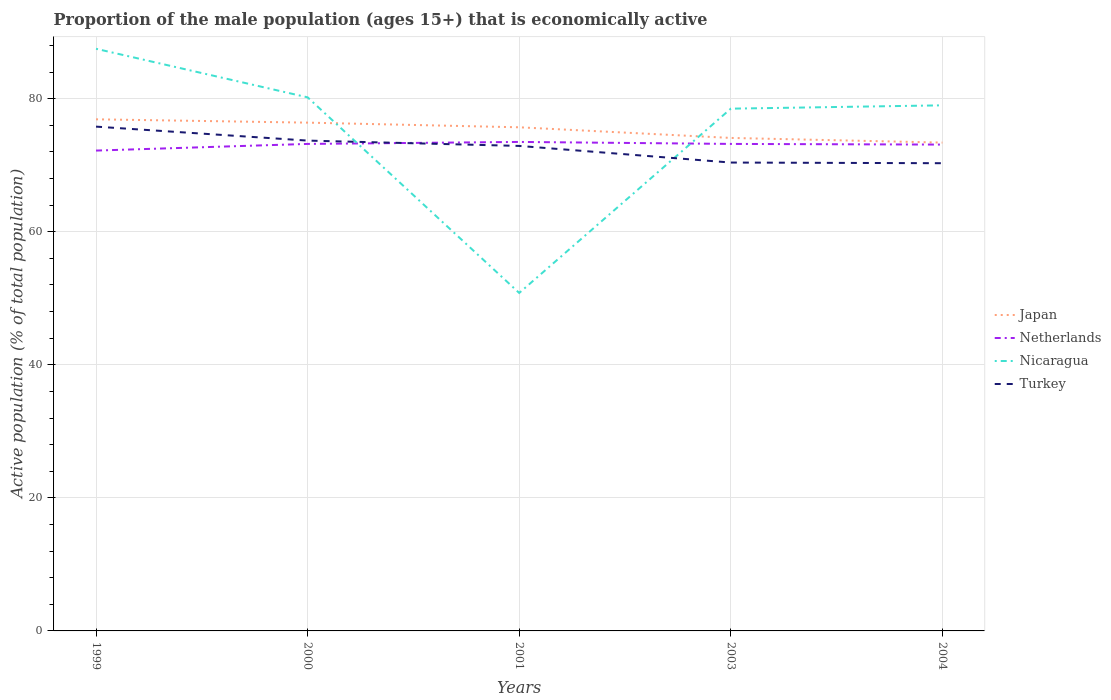Across all years, what is the maximum proportion of the male population that is economically active in Turkey?
Your answer should be very brief. 70.3. In which year was the proportion of the male population that is economically active in Netherlands maximum?
Provide a short and direct response. 1999. What is the total proportion of the male population that is economically active in Netherlands in the graph?
Provide a short and direct response. -1.3. What is the difference between the highest and the second highest proportion of the male population that is economically active in Japan?
Your answer should be very brief. 3.5. How many years are there in the graph?
Ensure brevity in your answer.  5. Are the values on the major ticks of Y-axis written in scientific E-notation?
Your response must be concise. No. Where does the legend appear in the graph?
Your answer should be very brief. Center right. How many legend labels are there?
Your response must be concise. 4. What is the title of the graph?
Your answer should be very brief. Proportion of the male population (ages 15+) that is economically active. Does "Tonga" appear as one of the legend labels in the graph?
Provide a short and direct response. No. What is the label or title of the X-axis?
Ensure brevity in your answer.  Years. What is the label or title of the Y-axis?
Keep it short and to the point. Active population (% of total population). What is the Active population (% of total population) in Japan in 1999?
Provide a succinct answer. 76.9. What is the Active population (% of total population) in Netherlands in 1999?
Make the answer very short. 72.2. What is the Active population (% of total population) of Nicaragua in 1999?
Offer a terse response. 87.5. What is the Active population (% of total population) of Turkey in 1999?
Provide a succinct answer. 75.8. What is the Active population (% of total population) in Japan in 2000?
Provide a succinct answer. 76.4. What is the Active population (% of total population) of Netherlands in 2000?
Your answer should be compact. 73.2. What is the Active population (% of total population) in Nicaragua in 2000?
Make the answer very short. 80.2. What is the Active population (% of total population) of Turkey in 2000?
Offer a terse response. 73.7. What is the Active population (% of total population) of Japan in 2001?
Your response must be concise. 75.7. What is the Active population (% of total population) in Netherlands in 2001?
Provide a succinct answer. 73.5. What is the Active population (% of total population) in Nicaragua in 2001?
Provide a succinct answer. 50.8. What is the Active population (% of total population) of Turkey in 2001?
Make the answer very short. 72.9. What is the Active population (% of total population) of Japan in 2003?
Keep it short and to the point. 74.1. What is the Active population (% of total population) of Netherlands in 2003?
Your response must be concise. 73.2. What is the Active population (% of total population) in Nicaragua in 2003?
Your response must be concise. 78.5. What is the Active population (% of total population) of Turkey in 2003?
Your answer should be compact. 70.4. What is the Active population (% of total population) in Japan in 2004?
Provide a short and direct response. 73.4. What is the Active population (% of total population) in Netherlands in 2004?
Offer a terse response. 73.1. What is the Active population (% of total population) in Nicaragua in 2004?
Give a very brief answer. 79. What is the Active population (% of total population) of Turkey in 2004?
Provide a short and direct response. 70.3. Across all years, what is the maximum Active population (% of total population) of Japan?
Your response must be concise. 76.9. Across all years, what is the maximum Active population (% of total population) of Netherlands?
Offer a terse response. 73.5. Across all years, what is the maximum Active population (% of total population) in Nicaragua?
Ensure brevity in your answer.  87.5. Across all years, what is the maximum Active population (% of total population) of Turkey?
Keep it short and to the point. 75.8. Across all years, what is the minimum Active population (% of total population) in Japan?
Make the answer very short. 73.4. Across all years, what is the minimum Active population (% of total population) of Netherlands?
Make the answer very short. 72.2. Across all years, what is the minimum Active population (% of total population) of Nicaragua?
Offer a very short reply. 50.8. Across all years, what is the minimum Active population (% of total population) in Turkey?
Make the answer very short. 70.3. What is the total Active population (% of total population) in Japan in the graph?
Your answer should be compact. 376.5. What is the total Active population (% of total population) of Netherlands in the graph?
Give a very brief answer. 365.2. What is the total Active population (% of total population) in Nicaragua in the graph?
Offer a very short reply. 376. What is the total Active population (% of total population) of Turkey in the graph?
Provide a succinct answer. 363.1. What is the difference between the Active population (% of total population) in Nicaragua in 1999 and that in 2000?
Ensure brevity in your answer.  7.3. What is the difference between the Active population (% of total population) in Nicaragua in 1999 and that in 2001?
Your answer should be compact. 36.7. What is the difference between the Active population (% of total population) of Netherlands in 1999 and that in 2003?
Offer a terse response. -1. What is the difference between the Active population (% of total population) in Nicaragua in 1999 and that in 2003?
Provide a short and direct response. 9. What is the difference between the Active population (% of total population) of Turkey in 1999 and that in 2003?
Your answer should be compact. 5.4. What is the difference between the Active population (% of total population) in Japan in 1999 and that in 2004?
Provide a succinct answer. 3.5. What is the difference between the Active population (% of total population) in Turkey in 1999 and that in 2004?
Provide a succinct answer. 5.5. What is the difference between the Active population (% of total population) in Japan in 2000 and that in 2001?
Your response must be concise. 0.7. What is the difference between the Active population (% of total population) of Nicaragua in 2000 and that in 2001?
Keep it short and to the point. 29.4. What is the difference between the Active population (% of total population) of Netherlands in 2000 and that in 2003?
Make the answer very short. 0. What is the difference between the Active population (% of total population) in Nicaragua in 2000 and that in 2003?
Ensure brevity in your answer.  1.7. What is the difference between the Active population (% of total population) of Turkey in 2000 and that in 2003?
Ensure brevity in your answer.  3.3. What is the difference between the Active population (% of total population) in Japan in 2000 and that in 2004?
Provide a short and direct response. 3. What is the difference between the Active population (% of total population) of Nicaragua in 2000 and that in 2004?
Your answer should be very brief. 1.2. What is the difference between the Active population (% of total population) in Japan in 2001 and that in 2003?
Your response must be concise. 1.6. What is the difference between the Active population (% of total population) of Netherlands in 2001 and that in 2003?
Your answer should be compact. 0.3. What is the difference between the Active population (% of total population) of Nicaragua in 2001 and that in 2003?
Offer a terse response. -27.7. What is the difference between the Active population (% of total population) of Nicaragua in 2001 and that in 2004?
Your answer should be compact. -28.2. What is the difference between the Active population (% of total population) of Turkey in 2001 and that in 2004?
Offer a very short reply. 2.6. What is the difference between the Active population (% of total population) of Netherlands in 2003 and that in 2004?
Offer a terse response. 0.1. What is the difference between the Active population (% of total population) in Japan in 1999 and the Active population (% of total population) in Netherlands in 2000?
Give a very brief answer. 3.7. What is the difference between the Active population (% of total population) in Netherlands in 1999 and the Active population (% of total population) in Turkey in 2000?
Provide a succinct answer. -1.5. What is the difference between the Active population (% of total population) of Nicaragua in 1999 and the Active population (% of total population) of Turkey in 2000?
Provide a short and direct response. 13.8. What is the difference between the Active population (% of total population) of Japan in 1999 and the Active population (% of total population) of Nicaragua in 2001?
Keep it short and to the point. 26.1. What is the difference between the Active population (% of total population) in Japan in 1999 and the Active population (% of total population) in Turkey in 2001?
Provide a succinct answer. 4. What is the difference between the Active population (% of total population) of Netherlands in 1999 and the Active population (% of total population) of Nicaragua in 2001?
Provide a short and direct response. 21.4. What is the difference between the Active population (% of total population) in Japan in 1999 and the Active population (% of total population) in Nicaragua in 2003?
Make the answer very short. -1.6. What is the difference between the Active population (% of total population) of Netherlands in 1999 and the Active population (% of total population) of Turkey in 2003?
Provide a short and direct response. 1.8. What is the difference between the Active population (% of total population) of Japan in 1999 and the Active population (% of total population) of Netherlands in 2004?
Offer a terse response. 3.8. What is the difference between the Active population (% of total population) in Japan in 2000 and the Active population (% of total population) in Netherlands in 2001?
Keep it short and to the point. 2.9. What is the difference between the Active population (% of total population) of Japan in 2000 and the Active population (% of total population) of Nicaragua in 2001?
Your answer should be compact. 25.6. What is the difference between the Active population (% of total population) of Japan in 2000 and the Active population (% of total population) of Turkey in 2001?
Your answer should be compact. 3.5. What is the difference between the Active population (% of total population) in Netherlands in 2000 and the Active population (% of total population) in Nicaragua in 2001?
Provide a short and direct response. 22.4. What is the difference between the Active population (% of total population) in Japan in 2000 and the Active population (% of total population) in Netherlands in 2003?
Give a very brief answer. 3.2. What is the difference between the Active population (% of total population) of Japan in 2000 and the Active population (% of total population) of Nicaragua in 2003?
Give a very brief answer. -2.1. What is the difference between the Active population (% of total population) of Japan in 2000 and the Active population (% of total population) of Turkey in 2003?
Offer a very short reply. 6. What is the difference between the Active population (% of total population) of Netherlands in 2000 and the Active population (% of total population) of Nicaragua in 2003?
Keep it short and to the point. -5.3. What is the difference between the Active population (% of total population) in Japan in 2000 and the Active population (% of total population) in Nicaragua in 2004?
Offer a very short reply. -2.6. What is the difference between the Active population (% of total population) in Japan in 2000 and the Active population (% of total population) in Turkey in 2004?
Your response must be concise. 6.1. What is the difference between the Active population (% of total population) in Nicaragua in 2000 and the Active population (% of total population) in Turkey in 2004?
Make the answer very short. 9.9. What is the difference between the Active population (% of total population) in Japan in 2001 and the Active population (% of total population) in Netherlands in 2003?
Provide a short and direct response. 2.5. What is the difference between the Active population (% of total population) of Japan in 2001 and the Active population (% of total population) of Nicaragua in 2003?
Make the answer very short. -2.8. What is the difference between the Active population (% of total population) in Netherlands in 2001 and the Active population (% of total population) in Nicaragua in 2003?
Keep it short and to the point. -5. What is the difference between the Active population (% of total population) of Nicaragua in 2001 and the Active population (% of total population) of Turkey in 2003?
Offer a very short reply. -19.6. What is the difference between the Active population (% of total population) of Japan in 2001 and the Active population (% of total population) of Nicaragua in 2004?
Offer a terse response. -3.3. What is the difference between the Active population (% of total population) of Japan in 2001 and the Active population (% of total population) of Turkey in 2004?
Offer a terse response. 5.4. What is the difference between the Active population (% of total population) in Netherlands in 2001 and the Active population (% of total population) in Turkey in 2004?
Keep it short and to the point. 3.2. What is the difference between the Active population (% of total population) in Nicaragua in 2001 and the Active population (% of total population) in Turkey in 2004?
Offer a terse response. -19.5. What is the difference between the Active population (% of total population) of Netherlands in 2003 and the Active population (% of total population) of Nicaragua in 2004?
Provide a succinct answer. -5.8. What is the average Active population (% of total population) of Japan per year?
Offer a terse response. 75.3. What is the average Active population (% of total population) of Netherlands per year?
Provide a short and direct response. 73.04. What is the average Active population (% of total population) of Nicaragua per year?
Offer a terse response. 75.2. What is the average Active population (% of total population) in Turkey per year?
Your answer should be compact. 72.62. In the year 1999, what is the difference between the Active population (% of total population) of Japan and Active population (% of total population) of Nicaragua?
Your answer should be compact. -10.6. In the year 1999, what is the difference between the Active population (% of total population) in Netherlands and Active population (% of total population) in Nicaragua?
Offer a terse response. -15.3. In the year 1999, what is the difference between the Active population (% of total population) of Netherlands and Active population (% of total population) of Turkey?
Keep it short and to the point. -3.6. In the year 1999, what is the difference between the Active population (% of total population) of Nicaragua and Active population (% of total population) of Turkey?
Give a very brief answer. 11.7. In the year 2000, what is the difference between the Active population (% of total population) of Japan and Active population (% of total population) of Nicaragua?
Offer a very short reply. -3.8. In the year 2000, what is the difference between the Active population (% of total population) in Japan and Active population (% of total population) in Turkey?
Provide a short and direct response. 2.7. In the year 2000, what is the difference between the Active population (% of total population) in Netherlands and Active population (% of total population) in Nicaragua?
Offer a terse response. -7. In the year 2000, what is the difference between the Active population (% of total population) of Nicaragua and Active population (% of total population) of Turkey?
Ensure brevity in your answer.  6.5. In the year 2001, what is the difference between the Active population (% of total population) in Japan and Active population (% of total population) in Nicaragua?
Provide a succinct answer. 24.9. In the year 2001, what is the difference between the Active population (% of total population) of Netherlands and Active population (% of total population) of Nicaragua?
Keep it short and to the point. 22.7. In the year 2001, what is the difference between the Active population (% of total population) of Netherlands and Active population (% of total population) of Turkey?
Your answer should be very brief. 0.6. In the year 2001, what is the difference between the Active population (% of total population) in Nicaragua and Active population (% of total population) in Turkey?
Offer a very short reply. -22.1. In the year 2003, what is the difference between the Active population (% of total population) in Japan and Active population (% of total population) in Nicaragua?
Your response must be concise. -4.4. In the year 2003, what is the difference between the Active population (% of total population) in Netherlands and Active population (% of total population) in Nicaragua?
Your answer should be compact. -5.3. In the year 2003, what is the difference between the Active population (% of total population) of Netherlands and Active population (% of total population) of Turkey?
Offer a very short reply. 2.8. In the year 2004, what is the difference between the Active population (% of total population) in Japan and Active population (% of total population) in Nicaragua?
Your response must be concise. -5.6. In the year 2004, what is the difference between the Active population (% of total population) in Japan and Active population (% of total population) in Turkey?
Provide a short and direct response. 3.1. In the year 2004, what is the difference between the Active population (% of total population) of Netherlands and Active population (% of total population) of Nicaragua?
Give a very brief answer. -5.9. What is the ratio of the Active population (% of total population) in Netherlands in 1999 to that in 2000?
Provide a succinct answer. 0.99. What is the ratio of the Active population (% of total population) in Nicaragua in 1999 to that in 2000?
Provide a short and direct response. 1.09. What is the ratio of the Active population (% of total population) in Turkey in 1999 to that in 2000?
Provide a succinct answer. 1.03. What is the ratio of the Active population (% of total population) of Japan in 1999 to that in 2001?
Your response must be concise. 1.02. What is the ratio of the Active population (% of total population) in Netherlands in 1999 to that in 2001?
Your answer should be very brief. 0.98. What is the ratio of the Active population (% of total population) of Nicaragua in 1999 to that in 2001?
Make the answer very short. 1.72. What is the ratio of the Active population (% of total population) in Turkey in 1999 to that in 2001?
Your answer should be compact. 1.04. What is the ratio of the Active population (% of total population) of Japan in 1999 to that in 2003?
Keep it short and to the point. 1.04. What is the ratio of the Active population (% of total population) of Netherlands in 1999 to that in 2003?
Provide a succinct answer. 0.99. What is the ratio of the Active population (% of total population) in Nicaragua in 1999 to that in 2003?
Your answer should be very brief. 1.11. What is the ratio of the Active population (% of total population) in Turkey in 1999 to that in 2003?
Your response must be concise. 1.08. What is the ratio of the Active population (% of total population) in Japan in 1999 to that in 2004?
Give a very brief answer. 1.05. What is the ratio of the Active population (% of total population) of Nicaragua in 1999 to that in 2004?
Provide a short and direct response. 1.11. What is the ratio of the Active population (% of total population) in Turkey in 1999 to that in 2004?
Make the answer very short. 1.08. What is the ratio of the Active population (% of total population) of Japan in 2000 to that in 2001?
Your response must be concise. 1.01. What is the ratio of the Active population (% of total population) in Netherlands in 2000 to that in 2001?
Provide a succinct answer. 1. What is the ratio of the Active population (% of total population) in Nicaragua in 2000 to that in 2001?
Give a very brief answer. 1.58. What is the ratio of the Active population (% of total population) of Japan in 2000 to that in 2003?
Your answer should be compact. 1.03. What is the ratio of the Active population (% of total population) in Nicaragua in 2000 to that in 2003?
Make the answer very short. 1.02. What is the ratio of the Active population (% of total population) in Turkey in 2000 to that in 2003?
Offer a terse response. 1.05. What is the ratio of the Active population (% of total population) in Japan in 2000 to that in 2004?
Ensure brevity in your answer.  1.04. What is the ratio of the Active population (% of total population) in Netherlands in 2000 to that in 2004?
Your answer should be very brief. 1. What is the ratio of the Active population (% of total population) in Nicaragua in 2000 to that in 2004?
Your answer should be compact. 1.02. What is the ratio of the Active population (% of total population) of Turkey in 2000 to that in 2004?
Make the answer very short. 1.05. What is the ratio of the Active population (% of total population) of Japan in 2001 to that in 2003?
Offer a terse response. 1.02. What is the ratio of the Active population (% of total population) in Netherlands in 2001 to that in 2003?
Provide a short and direct response. 1. What is the ratio of the Active population (% of total population) in Nicaragua in 2001 to that in 2003?
Make the answer very short. 0.65. What is the ratio of the Active population (% of total population) in Turkey in 2001 to that in 2003?
Offer a terse response. 1.04. What is the ratio of the Active population (% of total population) in Japan in 2001 to that in 2004?
Offer a terse response. 1.03. What is the ratio of the Active population (% of total population) in Netherlands in 2001 to that in 2004?
Make the answer very short. 1.01. What is the ratio of the Active population (% of total population) of Nicaragua in 2001 to that in 2004?
Offer a very short reply. 0.64. What is the ratio of the Active population (% of total population) of Turkey in 2001 to that in 2004?
Provide a short and direct response. 1.04. What is the ratio of the Active population (% of total population) in Japan in 2003 to that in 2004?
Provide a succinct answer. 1.01. What is the ratio of the Active population (% of total population) of Netherlands in 2003 to that in 2004?
Give a very brief answer. 1. What is the ratio of the Active population (% of total population) of Nicaragua in 2003 to that in 2004?
Your answer should be compact. 0.99. What is the ratio of the Active population (% of total population) of Turkey in 2003 to that in 2004?
Offer a very short reply. 1. What is the difference between the highest and the second highest Active population (% of total population) of Japan?
Your response must be concise. 0.5. What is the difference between the highest and the second highest Active population (% of total population) in Netherlands?
Ensure brevity in your answer.  0.3. What is the difference between the highest and the second highest Active population (% of total population) of Turkey?
Your response must be concise. 2.1. What is the difference between the highest and the lowest Active population (% of total population) in Nicaragua?
Provide a short and direct response. 36.7. What is the difference between the highest and the lowest Active population (% of total population) in Turkey?
Give a very brief answer. 5.5. 